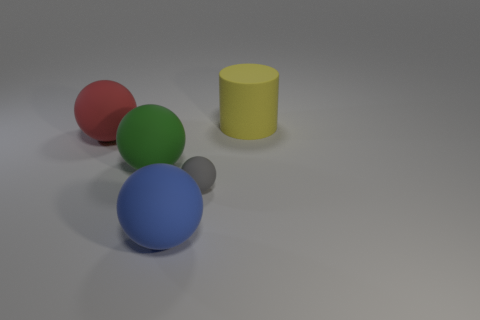Are there fewer small blue balls than green balls?
Provide a short and direct response. Yes. There is another tiny rubber thing that is the same shape as the green rubber object; what color is it?
Offer a terse response. Gray. Is there any other thing that is the same shape as the large yellow thing?
Keep it short and to the point. No. Is the number of blue matte spheres greater than the number of spheres?
Offer a very short reply. No. How many other objects are there of the same material as the large green ball?
Make the answer very short. 4. What is the shape of the big thing that is in front of the green matte thing left of the sphere that is right of the large blue rubber sphere?
Give a very brief answer. Sphere. Is the number of large balls behind the gray matte sphere less than the number of matte things that are right of the large green matte sphere?
Your answer should be very brief. Yes. Is there a matte cylinder that has the same color as the tiny matte thing?
Ensure brevity in your answer.  No. Is the yellow cylinder made of the same material as the large sphere that is on the right side of the large green thing?
Your answer should be very brief. Yes. Is there a matte object left of the large rubber object behind the red rubber sphere?
Your answer should be very brief. Yes. 